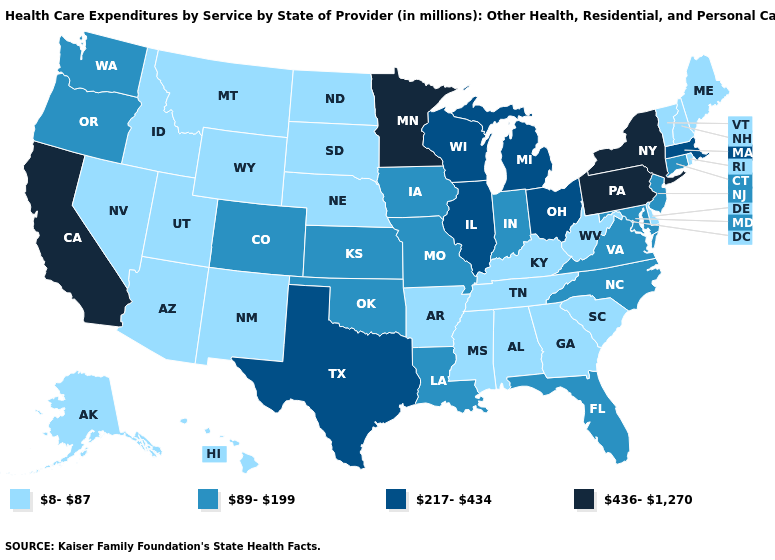What is the highest value in the Northeast ?
Give a very brief answer. 436-1,270. What is the highest value in the West ?
Be succinct. 436-1,270. Does South Dakota have a lower value than New Mexico?
Quick response, please. No. What is the value of Oklahoma?
Keep it brief. 89-199. Name the states that have a value in the range 89-199?
Keep it brief. Colorado, Connecticut, Florida, Indiana, Iowa, Kansas, Louisiana, Maryland, Missouri, New Jersey, North Carolina, Oklahoma, Oregon, Virginia, Washington. What is the lowest value in the USA?
Be succinct. 8-87. Name the states that have a value in the range 217-434?
Be succinct. Illinois, Massachusetts, Michigan, Ohio, Texas, Wisconsin. What is the highest value in states that border Pennsylvania?
Concise answer only. 436-1,270. Name the states that have a value in the range 8-87?
Quick response, please. Alabama, Alaska, Arizona, Arkansas, Delaware, Georgia, Hawaii, Idaho, Kentucky, Maine, Mississippi, Montana, Nebraska, Nevada, New Hampshire, New Mexico, North Dakota, Rhode Island, South Carolina, South Dakota, Tennessee, Utah, Vermont, West Virginia, Wyoming. Name the states that have a value in the range 8-87?
Keep it brief. Alabama, Alaska, Arizona, Arkansas, Delaware, Georgia, Hawaii, Idaho, Kentucky, Maine, Mississippi, Montana, Nebraska, Nevada, New Hampshire, New Mexico, North Dakota, Rhode Island, South Carolina, South Dakota, Tennessee, Utah, Vermont, West Virginia, Wyoming. Does Wyoming have the lowest value in the West?
Concise answer only. Yes. Which states have the highest value in the USA?
Write a very short answer. California, Minnesota, New York, Pennsylvania. Which states hav the highest value in the MidWest?
Give a very brief answer. Minnesota. What is the highest value in states that border Texas?
Quick response, please. 89-199. 